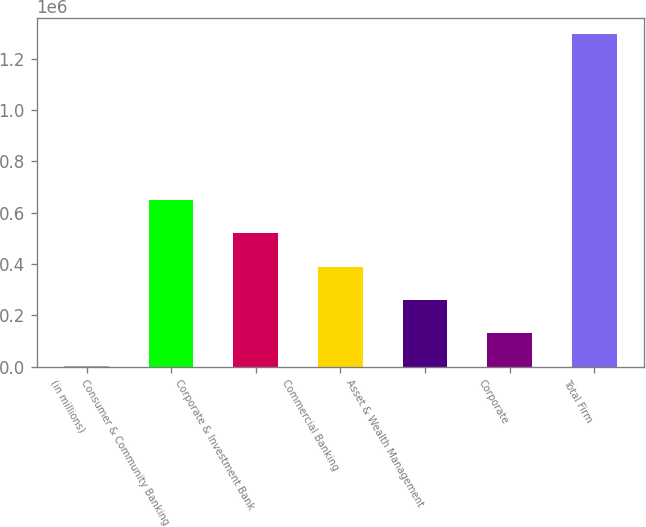Convert chart. <chart><loc_0><loc_0><loc_500><loc_500><bar_chart><fcel>(in millions)<fcel>Consumer & Community Banking<fcel>Corporate & Investment Bank<fcel>Commercial Banking<fcel>Asset & Wealth Management<fcel>Corporate<fcel>Total Firm<nl><fcel>2015<fcel>648902<fcel>519524<fcel>390147<fcel>260770<fcel>131392<fcel>1.29579e+06<nl></chart> 